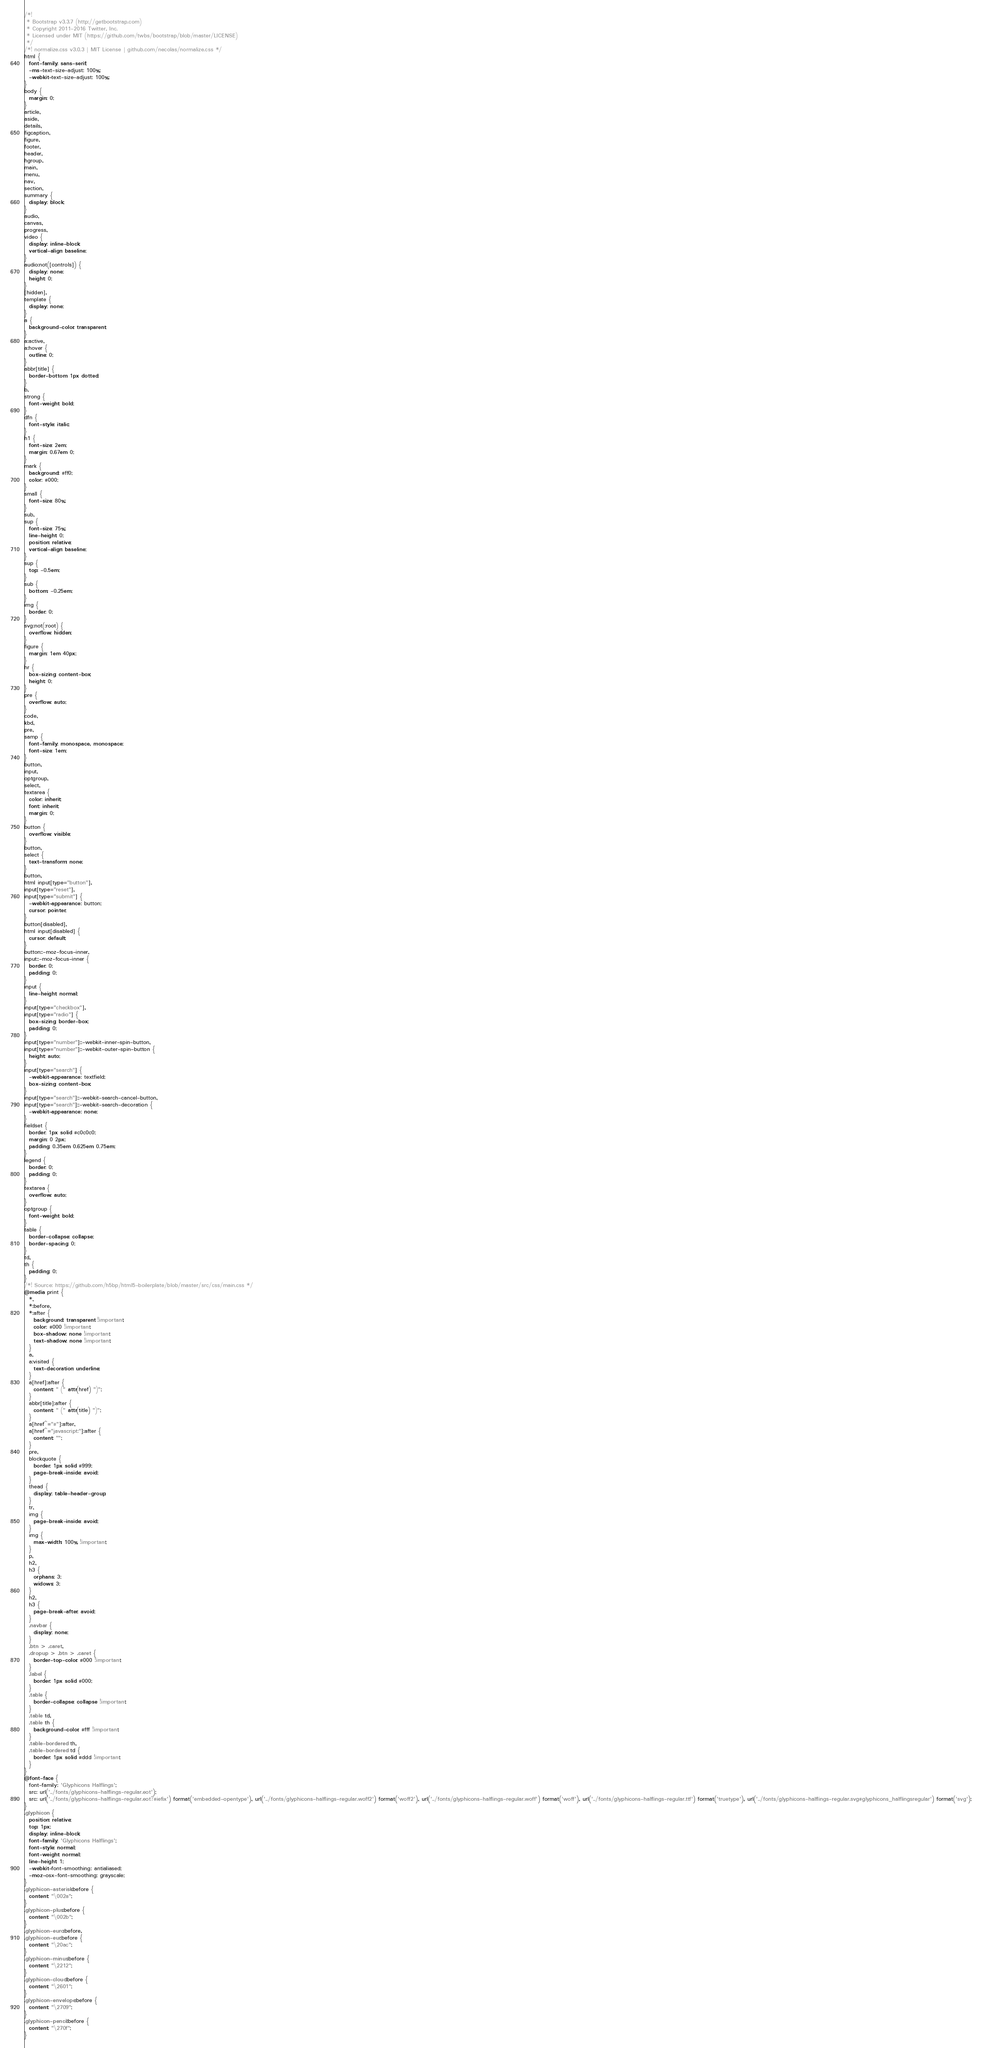<code> <loc_0><loc_0><loc_500><loc_500><_CSS_>/*!
 * Bootstrap v3.3.7 (http://getbootstrap.com)
 * Copyright 2011-2016 Twitter, Inc.
 * Licensed under MIT (https://github.com/twbs/bootstrap/blob/master/LICENSE)
 */
/*! normalize.css v3.0.3 | MIT License | github.com/necolas/normalize.css */
html {
  font-family: sans-serif;
  -ms-text-size-adjust: 100%;
  -webkit-text-size-adjust: 100%;
}
body {
  margin: 0;
}
article,
aside,
details,
figcaption,
figure,
footer,
header,
hgroup,
main,
menu,
nav,
section,
summary {
  display: block;
}
audio,
canvas,
progress,
video {
  display: inline-block;
  vertical-align: baseline;
}
audio:not([controls]) {
  display: none;
  height: 0;
}
[hidden],
template {
  display: none;
}
a {
  background-color: transparent;
}
a:active,
a:hover {
  outline: 0;
}
abbr[title] {
  border-bottom: 1px dotted;
}
b,
strong {
  font-weight: bold;
}
dfn {
  font-style: italic;
}
h1 {
  font-size: 2em;
  margin: 0.67em 0;
}
mark {
  background: #ff0;
  color: #000;
}
small {
  font-size: 80%;
}
sub,
sup {
  font-size: 75%;
  line-height: 0;
  position: relative;
  vertical-align: baseline;
}
sup {
  top: -0.5em;
}
sub {
  bottom: -0.25em;
}
img {
  border: 0;
}
svg:not(:root) {
  overflow: hidden;
}
figure {
  margin: 1em 40px;
}
hr {
  box-sizing: content-box;
  height: 0;
}
pre {
  overflow: auto;
}
code,
kbd,
pre,
samp {
  font-family: monospace, monospace;
  font-size: 1em;
}
button,
input,
optgroup,
select,
textarea {
  color: inherit;
  font: inherit;
  margin: 0;
}
button {
  overflow: visible;
}
button,
select {
  text-transform: none;
}
button,
html input[type="button"],
input[type="reset"],
input[type="submit"] {
  -webkit-appearance: button;
  cursor: pointer;
}
button[disabled],
html input[disabled] {
  cursor: default;
}
button::-moz-focus-inner,
input::-moz-focus-inner {
  border: 0;
  padding: 0;
}
input {
  line-height: normal;
}
input[type="checkbox"],
input[type="radio"] {
  box-sizing: border-box;
  padding: 0;
}
input[type="number"]::-webkit-inner-spin-button,
input[type="number"]::-webkit-outer-spin-button {
  height: auto;
}
input[type="search"] {
  -webkit-appearance: textfield;
  box-sizing: content-box;
}
input[type="search"]::-webkit-search-cancel-button,
input[type="search"]::-webkit-search-decoration {
  -webkit-appearance: none;
}
fieldset {
  border: 1px solid #c0c0c0;
  margin: 0 2px;
  padding: 0.35em 0.625em 0.75em;
}
legend {
  border: 0;
  padding: 0;
}
textarea {
  overflow: auto;
}
optgroup {
  font-weight: bold;
}
table {
  border-collapse: collapse;
  border-spacing: 0;
}
td,
th {
  padding: 0;
}
/*! Source: https://github.com/h5bp/html5-boilerplate/blob/master/src/css/main.css */
@media print {
  *,
  *:before,
  *:after {
    background: transparent !important;
    color: #000 !important;
    box-shadow: none !important;
    text-shadow: none !important;
  }
  a,
  a:visited {
    text-decoration: underline;
  }
  a[href]:after {
    content: " (" attr(href) ")";
  }
  abbr[title]:after {
    content: " (" attr(title) ")";
  }
  a[href^="#"]:after,
  a[href^="javascript:"]:after {
    content: "";
  }
  pre,
  blockquote {
    border: 1px solid #999;
    page-break-inside: avoid;
  }
  thead {
    display: table-header-group;
  }
  tr,
  img {
    page-break-inside: avoid;
  }
  img {
    max-width: 100% !important;
  }
  p,
  h2,
  h3 {
    orphans: 3;
    widows: 3;
  }
  h2,
  h3 {
    page-break-after: avoid;
  }
  .navbar {
    display: none;
  }
  .btn > .caret,
  .dropup > .btn > .caret {
    border-top-color: #000 !important;
  }
  .label {
    border: 1px solid #000;
  }
  .table {
    border-collapse: collapse !important;
  }
  .table td,
  .table th {
    background-color: #fff !important;
  }
  .table-bordered th,
  .table-bordered td {
    border: 1px solid #ddd !important;
  }
}
@font-face {
  font-family: 'Glyphicons Halflings';
  src: url('../fonts/glyphicons-halflings-regular.eot');
  src: url('../fonts/glyphicons-halflings-regular.eot?#iefix') format('embedded-opentype'), url('../fonts/glyphicons-halflings-regular.woff2') format('woff2'), url('../fonts/glyphicons-halflings-regular.woff') format('woff'), url('../fonts/glyphicons-halflings-regular.ttf') format('truetype'), url('../fonts/glyphicons-halflings-regular.svg#glyphicons_halflingsregular') format('svg');
}
.glyphicon {
  position: relative;
  top: 1px;
  display: inline-block;
  font-family: 'Glyphicons Halflings';
  font-style: normal;
  font-weight: normal;
  line-height: 1;
  -webkit-font-smoothing: antialiased;
  -moz-osx-font-smoothing: grayscale;
}
.glyphicon-asterisk:before {
  content: "\002a";
}
.glyphicon-plus:before {
  content: "\002b";
}
.glyphicon-euro:before,
.glyphicon-eur:before {
  content: "\20ac";
}
.glyphicon-minus:before {
  content: "\2212";
}
.glyphicon-cloud:before {
  content: "\2601";
}
.glyphicon-envelope:before {
  content: "\2709";
}
.glyphicon-pencil:before {
  content: "\270f";
}</code> 